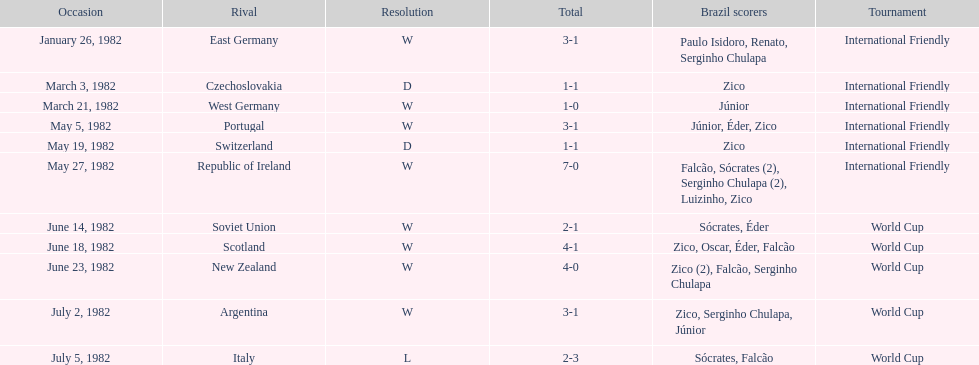What date is at the top of the list? January 26, 1982. 